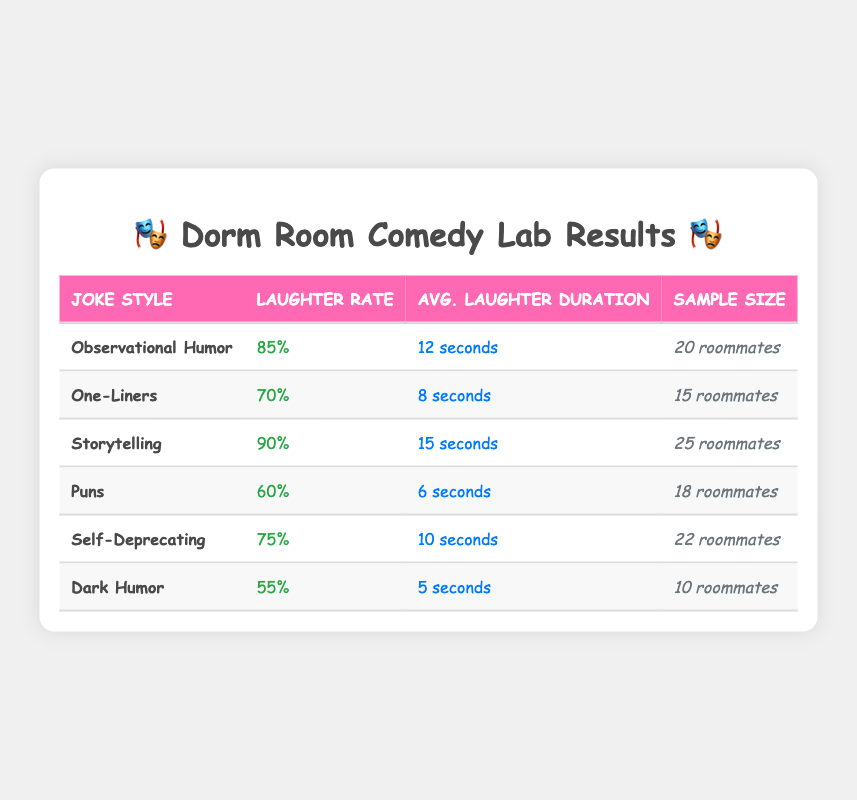What's the highest laughter rate percentage among the joke styles? The table lists the laughter rate percentages for different joke styles. Observational Humor has a percentage of 85, One-Liners has 70, Storytelling has 90, Puns has 60, Self-Deprecating has 75, and Dark Humor has 55. The highest percentage is for Storytelling at 90.
Answer: 90 Which joke style had the longest average laughter duration? The average laughter durations are provided for each joke style: Observational Humor is 12 seconds, One-Liners is 8 seconds, Storytelling is 15 seconds, Puns is 6 seconds, Self-Deprecating is 10 seconds, and Dark Humor is 5 seconds. The longest duration is for Storytelling at 15 seconds.
Answer: 15 seconds How many roommates provided feedback for Puns? The table states the sample sizes for various joke styles. For Puns, the sample size is 18 roommates.
Answer: 18 roommates True or False: The laughter rate for Dark Humor is higher than for Self-Deprecating. The table shows that Dark Humor has a laughter rate of 55%, while Self-Deprecating has a rate of 75%. Since 55 is less than 75, the statement is false.
Answer: False If you combine the laughter rates of One-Liners and Puns, are they less than the laughter rate of Self-Deprecating? The laughter rates for One-Liners and Puns are 70% and 60%, respectively. Adding these gives 70 + 60 = 130%. The laughter rate for Self-Deprecating is 75%. Since 130% is greater than 75%, the result is not less.
Answer: No What is the average laughter duration of all the joke styles? To find the average, sum the average laughter durations: 12 + 8 + 15 + 6 + 10 + 5 = 56 seconds. There are 6 joke styles, so the average is 56/6 = 9.33 seconds.
Answer: 9.33 seconds Which joke style has the lowest laughter rate and what is that rate? The laughter rate of each joke style shows that Dark Humor has the lowest laughter rate at 55%.
Answer: 55% How does the laughter rate for Storytelling compare to that of Puns? The table shows that Storytelling has a laughter rate of 90%, while Puns has a rate of 60%. Comparing these, 90% is higher than 60%. Therefore, Storytelling has a significantly higher laughter rate than Puns.
Answer: Higher than Puns 